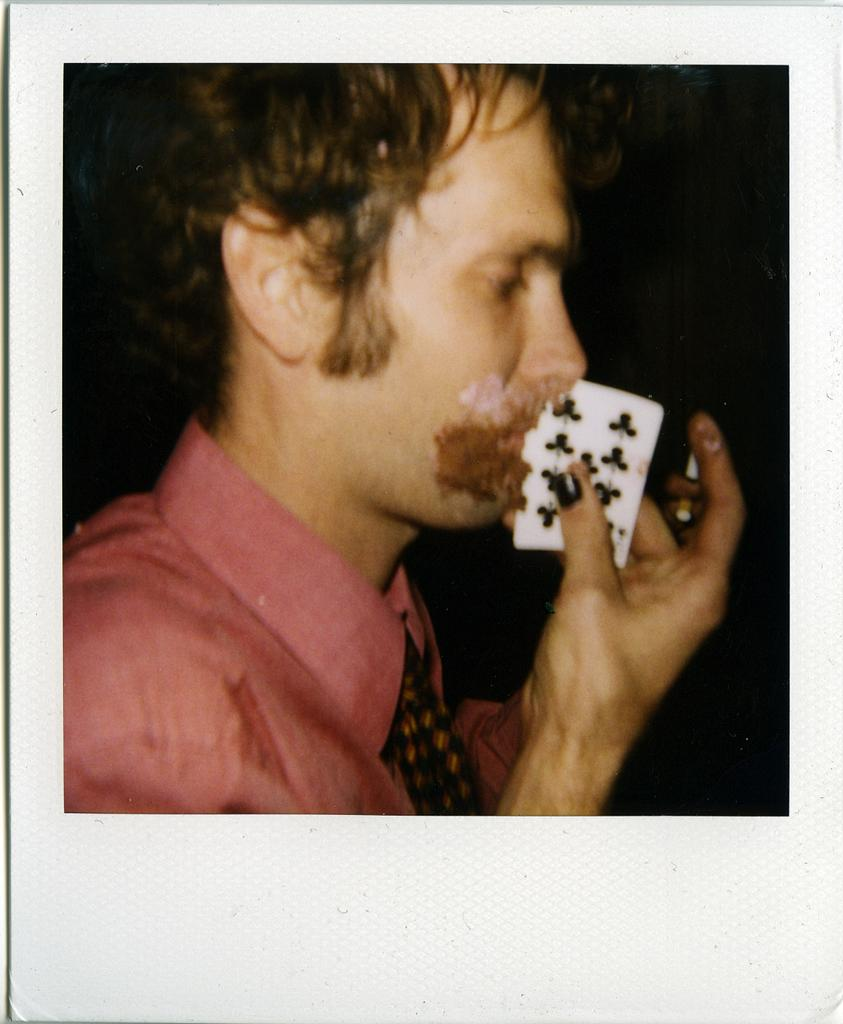What is the main subject of the image? The main subject of the image is a photo of a picture. What can be seen in the picture? The picture contains a person. What is the person wearing in the picture? The person is wearing clothes in the picture. What is the person holding in the picture? The person is holding a card with their hand in the picture. What type of fuel is being used by the person in the picture? There is no mention of fuel in the image, as it features a person holding a card in a picture. 